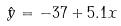<formula> <loc_0><loc_0><loc_500><loc_500>\hat { y } = - 3 7 + 5 . 1 x</formula> 